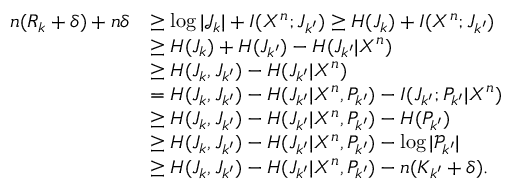<formula> <loc_0><loc_0><loc_500><loc_500>\begin{array} { r l } { n ( R _ { k } + \delta ) + n \delta } & { \geq \log | \mathcal { J } _ { k } | + I ( X ^ { n } ; J _ { k ^ { \prime } } ) \geq H ( J _ { k } ) + I ( X ^ { n } ; J _ { k ^ { \prime } } ) } \\ & { \geq H ( J _ { k } ) + H ( J _ { k ^ { \prime } } ) - H ( J _ { k ^ { \prime } } | X ^ { n } ) } \\ & { \geq H ( J _ { k } , J _ { k ^ { \prime } } ) - H ( J _ { k ^ { \prime } } | X ^ { n } ) } \\ & { = H ( J _ { k } , J _ { k ^ { \prime } } ) - H ( J _ { k ^ { \prime } } | X ^ { n } , P _ { k ^ { \prime } } ) - I ( J _ { k ^ { \prime } } ; P _ { k ^ { \prime } } | X ^ { n } ) } \\ & { \geq H ( J _ { k } , J _ { k ^ { \prime } } ) - H ( J _ { k ^ { \prime } } | X ^ { n } , P _ { k ^ { \prime } } ) - H ( P _ { k ^ { \prime } } ) } \\ & { \geq H ( J _ { k } , J _ { k ^ { \prime } } ) - H ( J _ { k ^ { \prime } } | X ^ { n } , P _ { k ^ { \prime } } ) - \log | \mathcal { P } _ { k ^ { \prime } } | } \\ & { \geq H ( J _ { k } , J _ { k ^ { \prime } } ) - H ( J _ { k ^ { \prime } } | X ^ { n } , P _ { k ^ { \prime } } ) - n ( K _ { k ^ { \prime } } + \delta ) . } \end{array}</formula> 